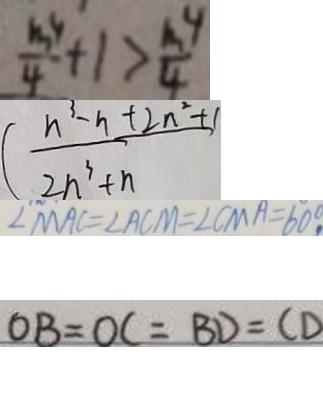Convert formula to latex. <formula><loc_0><loc_0><loc_500><loc_500>\frac { m ^ { 4 } } { 4 } + 1 > \frac { m ^ { 4 } } { 4 } 
 ( \frac { n ^ { 3 } - n + 2 n ^ { 2 } + 1 } { 2 n ^ { 3 } + n } 
 \angle M A C = \angle A C M = \angle C M A = 6 0 ^ { \circ } 
 O B = O C = B D = C D</formula> 